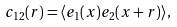Convert formula to latex. <formula><loc_0><loc_0><loc_500><loc_500>c _ { 1 2 } ( r ) = \langle e _ { 1 } ( { x } ) e _ { 2 } ( { x } + { r } ) \rangle ,</formula> 